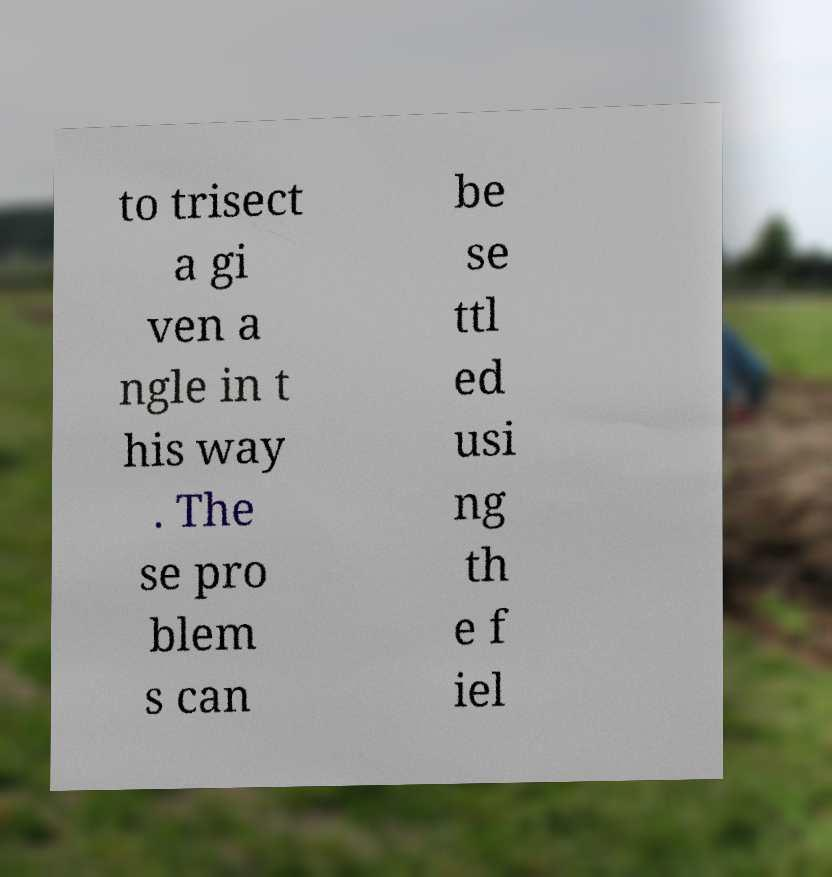Could you extract and type out the text from this image? to trisect a gi ven a ngle in t his way . The se pro blem s can be se ttl ed usi ng th e f iel 